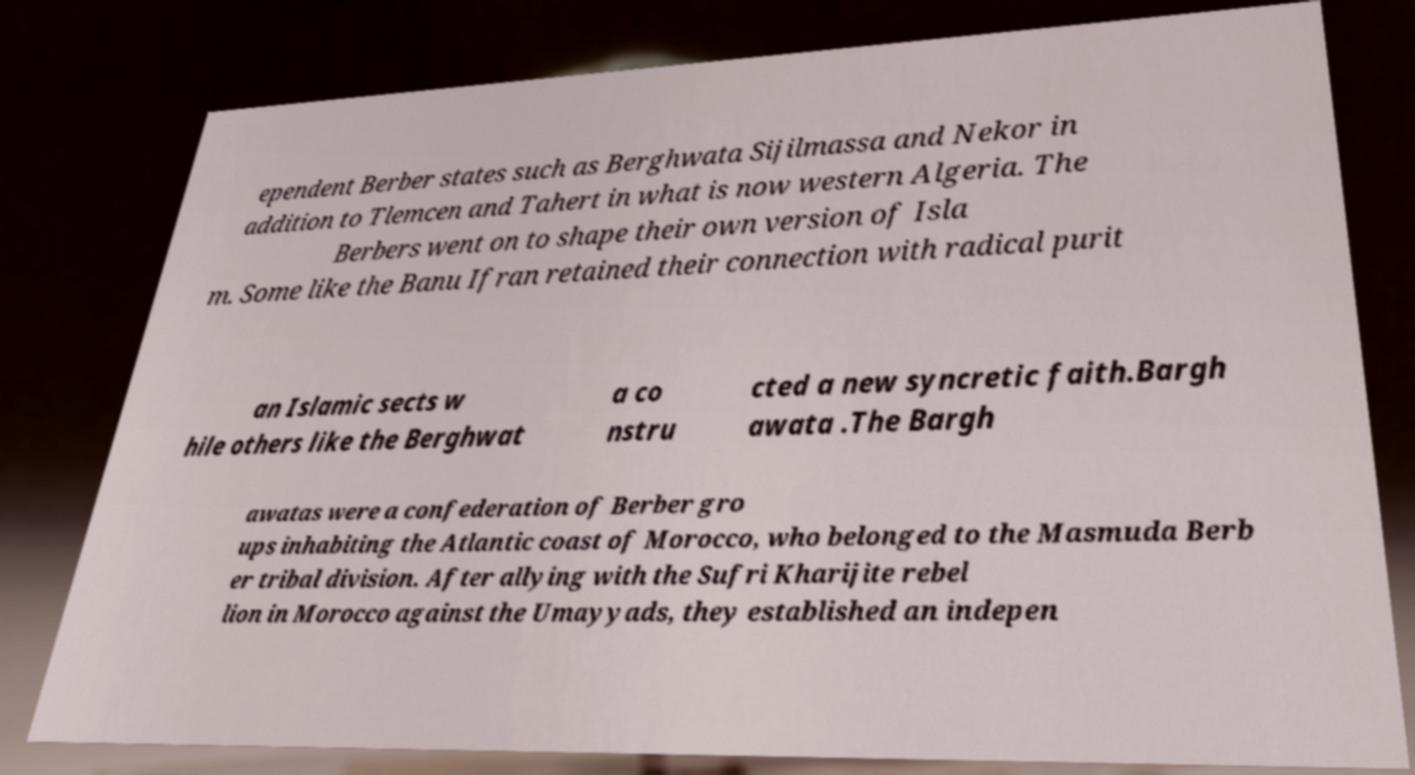What messages or text are displayed in this image? I need them in a readable, typed format. ependent Berber states such as Berghwata Sijilmassa and Nekor in addition to Tlemcen and Tahert in what is now western Algeria. The Berbers went on to shape their own version of Isla m. Some like the Banu Ifran retained their connection with radical purit an Islamic sects w hile others like the Berghwat a co nstru cted a new syncretic faith.Bargh awata .The Bargh awatas were a confederation of Berber gro ups inhabiting the Atlantic coast of Morocco, who belonged to the Masmuda Berb er tribal division. After allying with the Sufri Kharijite rebel lion in Morocco against the Umayyads, they established an indepen 